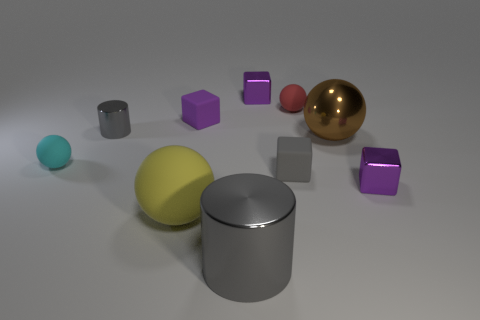Are there any small purple rubber blocks on the right side of the gray metal cylinder that is in front of the large brown ball?
Make the answer very short. No. What number of purple cylinders have the same size as the brown shiny object?
Provide a succinct answer. 0. There is a purple metal thing that is in front of the small purple thing left of the big gray thing; how many gray things are behind it?
Your answer should be very brief. 2. How many small metallic objects are in front of the small cyan ball and on the left side of the big gray metal thing?
Ensure brevity in your answer.  0. Is there any other thing of the same color as the large rubber thing?
Offer a terse response. No. What number of metallic things are either small red things or big purple objects?
Your answer should be very brief. 0. What is the material of the gray cylinder that is behind the purple shiny block in front of the tiny purple shiny cube that is on the left side of the red matte object?
Provide a succinct answer. Metal. There is a tiny purple block that is to the left of the purple block behind the red object; what is its material?
Ensure brevity in your answer.  Rubber. There is a purple matte block that is to the right of the tiny cylinder; is it the same size as the gray cylinder behind the large shiny cylinder?
Your answer should be compact. Yes. Are there any other things that are made of the same material as the brown ball?
Your answer should be very brief. Yes. 